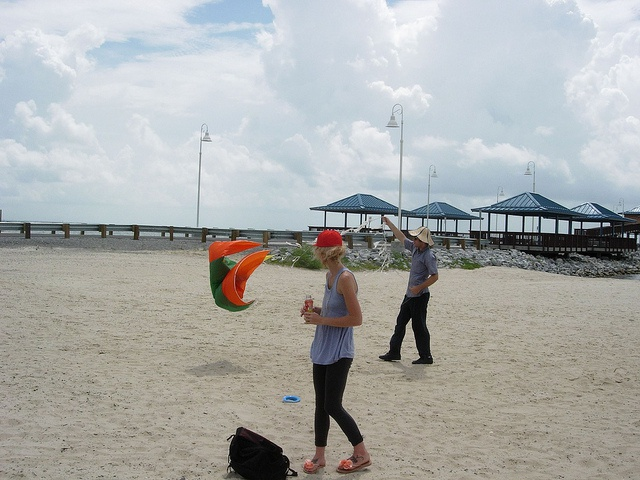Describe the objects in this image and their specific colors. I can see people in lightgray, black, gray, brown, and maroon tones, people in lightgray, black, gray, and maroon tones, kite in lightgray, brown, black, red, and darkgreen tones, backpack in lightgray, black, darkgray, and gray tones, and handbag in lightgray, black, gray, and darkgray tones in this image. 